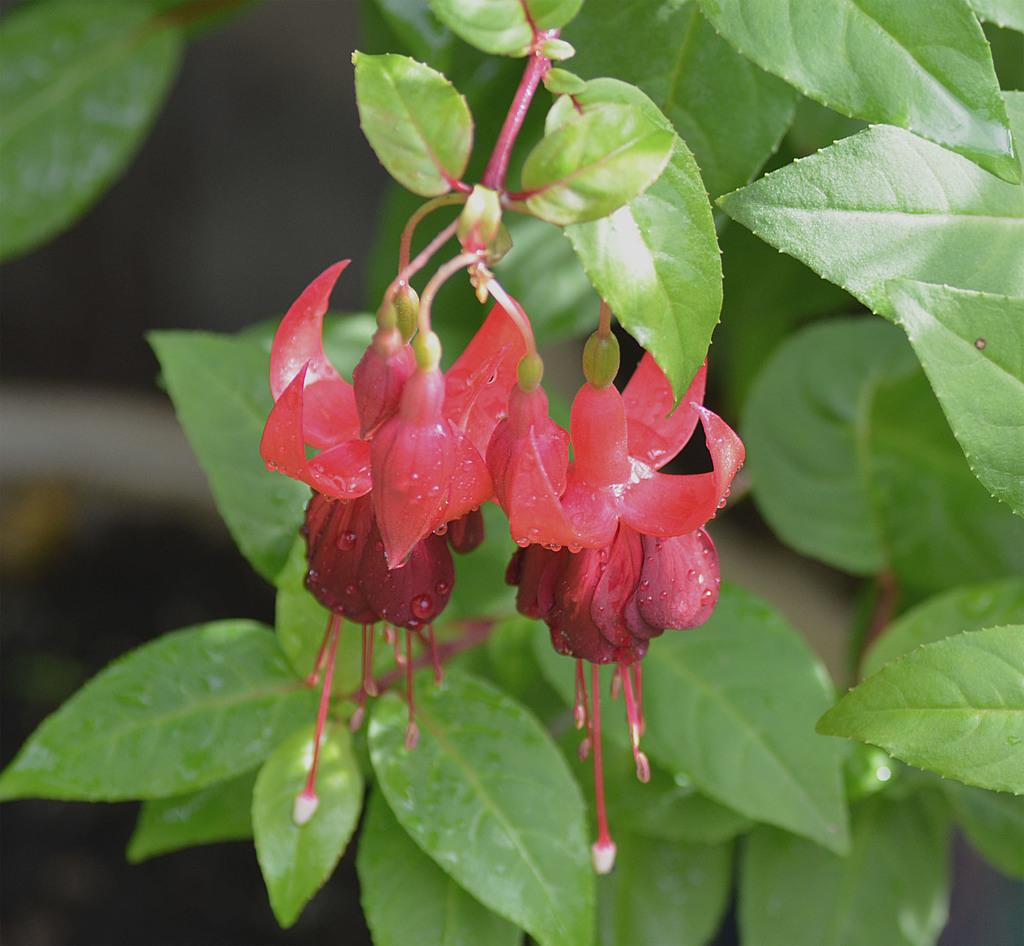What type of plants can be seen in the image? There are flowers and leaves in the image. Can you describe the background of the image? The background of the image is blurred. What type of railway is visible in the image? There is no railway present in the image. How many trucks can be seen in the image? There are no trucks present in the image. 